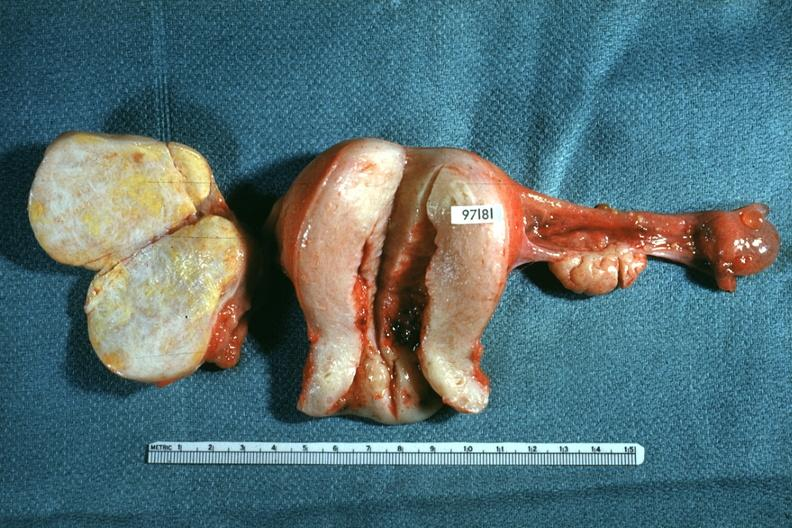where does this belong to?
Answer the question using a single word or phrase. Female reproductive system 